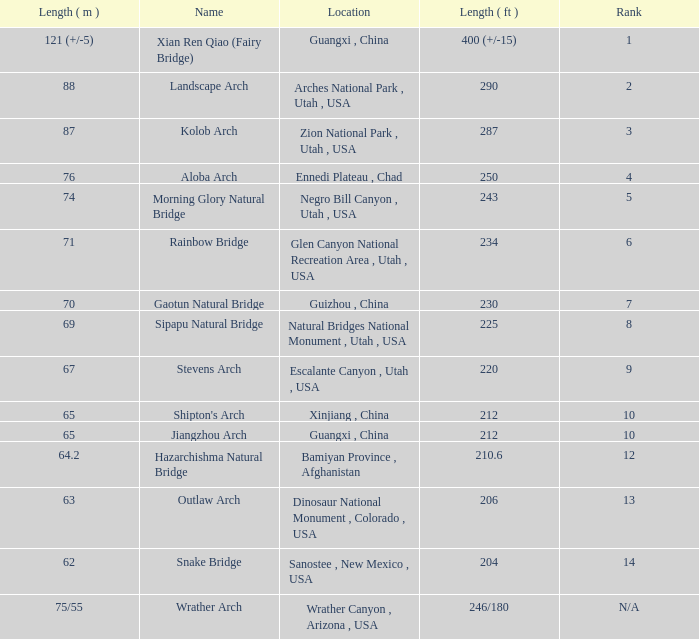Where is the longest arch with a length in meters of 64.2? Bamiyan Province , Afghanistan. 